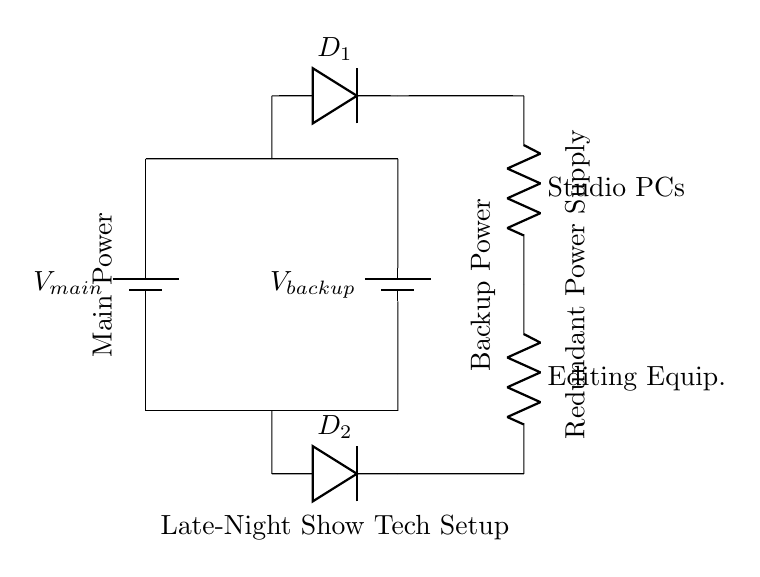What are the two types of power supplies shown? The diagram shows a main power supply and a backup power supply, indicated by the labels next to each battery.
Answer: main, backup What component connects the two power supplies in parallel? The circuit diagram features short connections that join both power supplies at the top and the bottom, allowing both to power the load simultaneously.
Answer: short connections What do the diodes represent in this circuit? The diodes are used to control the direction of current flow from each power supply, ensuring that power is supplied from the main if available, or from the backup if the main fails.
Answer: current control How many components are listed in the load section? The diagram labels two resistors representing Studio PCs and Editing Equipment, indicating that there are two components in the load section.
Answer: two Which power supply is labeled as the backup? The voltage labeled as V_backup is positioned on the right side of the circuit and connected to the load through diodes.
Answer: V_backup What would happen if the main power supply fails? If the main power supply fails, the load would continue to be powered by the backup supply, as indicated by the design and operation of the diodes allowing current to flow from the backup source exclusively.
Answer: switch to backup What is the purpose of a redundant power supply system? The purpose is to ensure continuous operation of equipment by providing an alternate power source in case the main supply fails, which is crucial for critical setups like studio computers.
Answer: continuous operation 